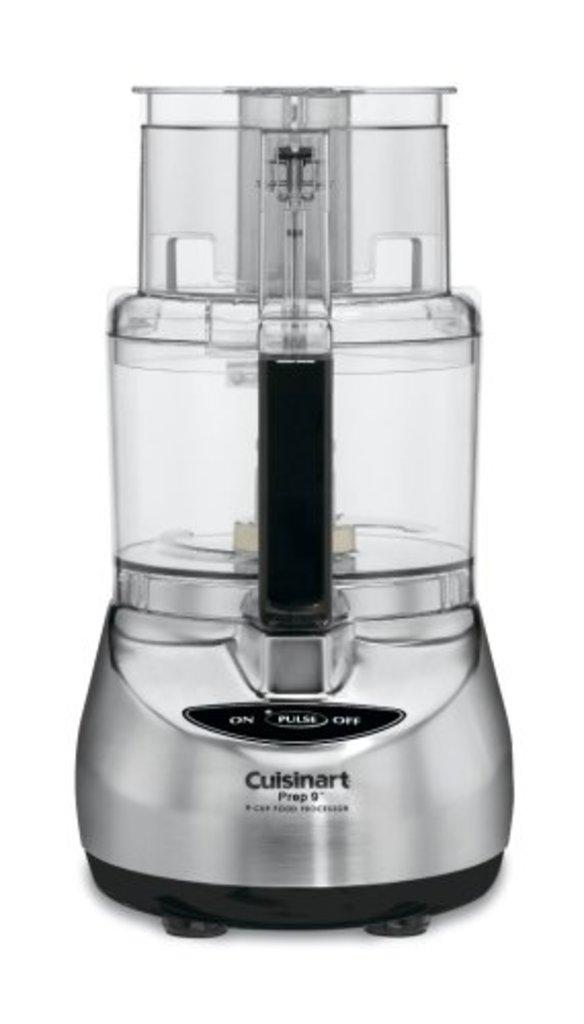<image>
Offer a succinct explanation of the picture presented. A blender made by Cuisinart, that is silver and see through. 